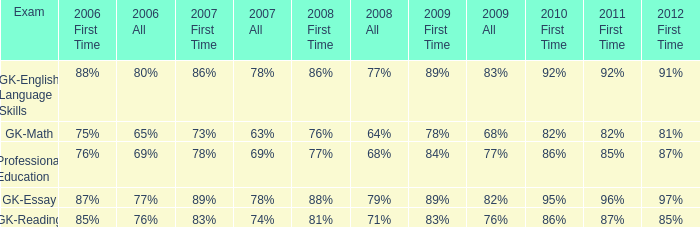What is the percentage for all in 2008 when all in 2007 was 69%? 68%. I'm looking to parse the entire table for insights. Could you assist me with that? {'header': ['Exam', '2006 First Time', '2006 All', '2007 First Time', '2007 All', '2008 First Time', '2008 All', '2009 First Time', '2009 All', '2010 First Time', '2011 First Time', '2012 First Time'], 'rows': [['GK-English Language Skills', '88%', '80%', '86%', '78%', '86%', '77%', '89%', '83%', '92%', '92%', '91%'], ['GK-Math', '75%', '65%', '73%', '63%', '76%', '64%', '78%', '68%', '82%', '82%', '81%'], ['Professional Education', '76%', '69%', '78%', '69%', '77%', '68%', '84%', '77%', '86%', '85%', '87%'], ['GK-Essay', '87%', '77%', '89%', '78%', '88%', '79%', '89%', '82%', '95%', '96%', '97%'], ['GK-Reading', '85%', '76%', '83%', '74%', '81%', '71%', '83%', '76%', '86%', '87%', '85%']]} 